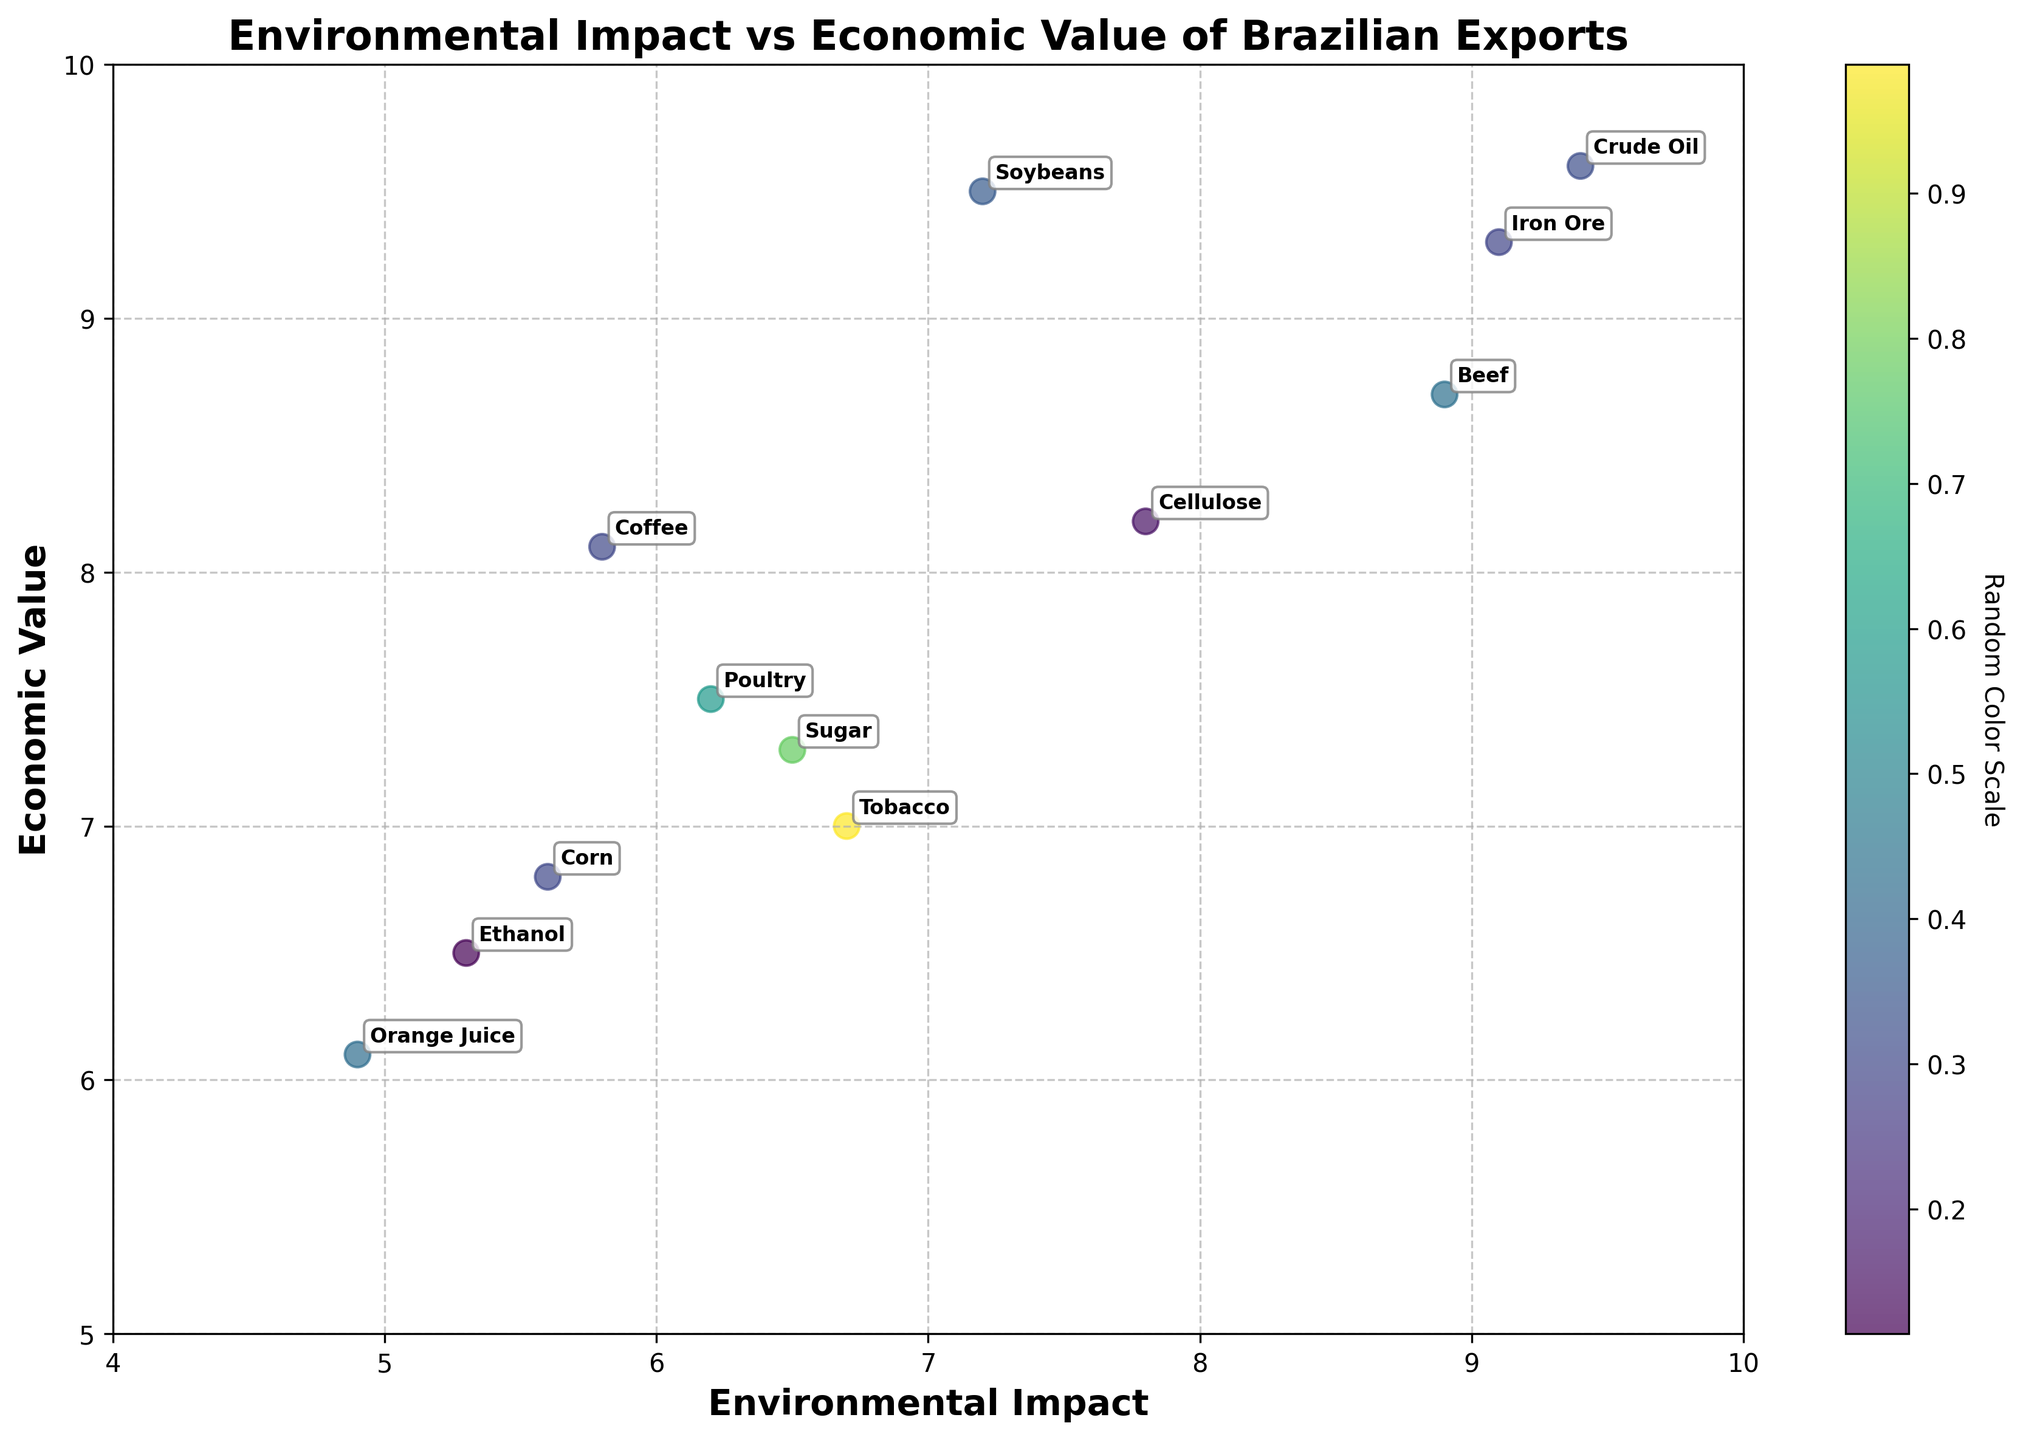What is the title of the plot? The title of the plot appears at the top of the figure and provides an overview of the content being visualized. In this case, it indicates the comparison between environmental impact and economic value of Brazilian exports.
Answer: Environmental Impact vs Economic Value of Brazilian Exports What are the axis labels of the plot? The axis labels are located along the horizontal and vertical axes of the figure and describe what each axis represents. The x-axis describes 'Environmental Impact,' while the y-axis describes 'Economic Value'.
Answer: Environmental Impact (x-axis), Economic Value (y-axis) How many different products are being compared in the plot? There are individual data points plotted and labeled according to each product. By counting these labeled data points, we can determine the number of unique products.
Answer: 12 Which product has the highest economic value? To find the product with the highest economic value, look for the point that is furthest up along the y-axis. Given the data, this product is Crude Oil.
Answer: Crude Oil Which product has the lowest environmental impact? To identify the product with the lowest environmental impact, look for the point that is furthest to the left on the x-axis. Given the data, this product is Orange Juice.
Answer: Orange Juice What is the average economic value of the products? The average can be calculated by summing the economic values of all products and dividing by the number of products. \[(9.5 + 8.1 + 7.3 + 8.7 + 9.3 + 9.6 + 6.8 + 7.5 + 8.2 + 6.1 + 7.0 + 6.5) / 12 = 8.0\]
Answer: 8.0 Which products have an environmental impact greater than 8? Identify the points located to the right of the 8-mark on the x-axis. These products are Beef, Iron Ore, and Crude Oil.
Answer: Beef, Iron Ore, Crude Oil Do any products have both an environmental impact and economic value above 9? Look for points located above the 9-mark on both the x-axis and y-axis. The data indicates only Crude Oil falls into this category.
Answer: Crude Oil What is the difference in economic value between the product with the highest and lowest economic values? First, identify Crude Oil with the highest economic value (9.6) and Orange Juice with the lowest (6.1), and calculate the difference \[9.6 - 6.1 = 3.5\].
Answer: 3.5 Which product has the highest environmental impact? To find the product with the highest environmental impact, look for the point positioned furthest to the right along the x-axis. Given the data, this product is Crude Oil.
Answer: Crude Oil 